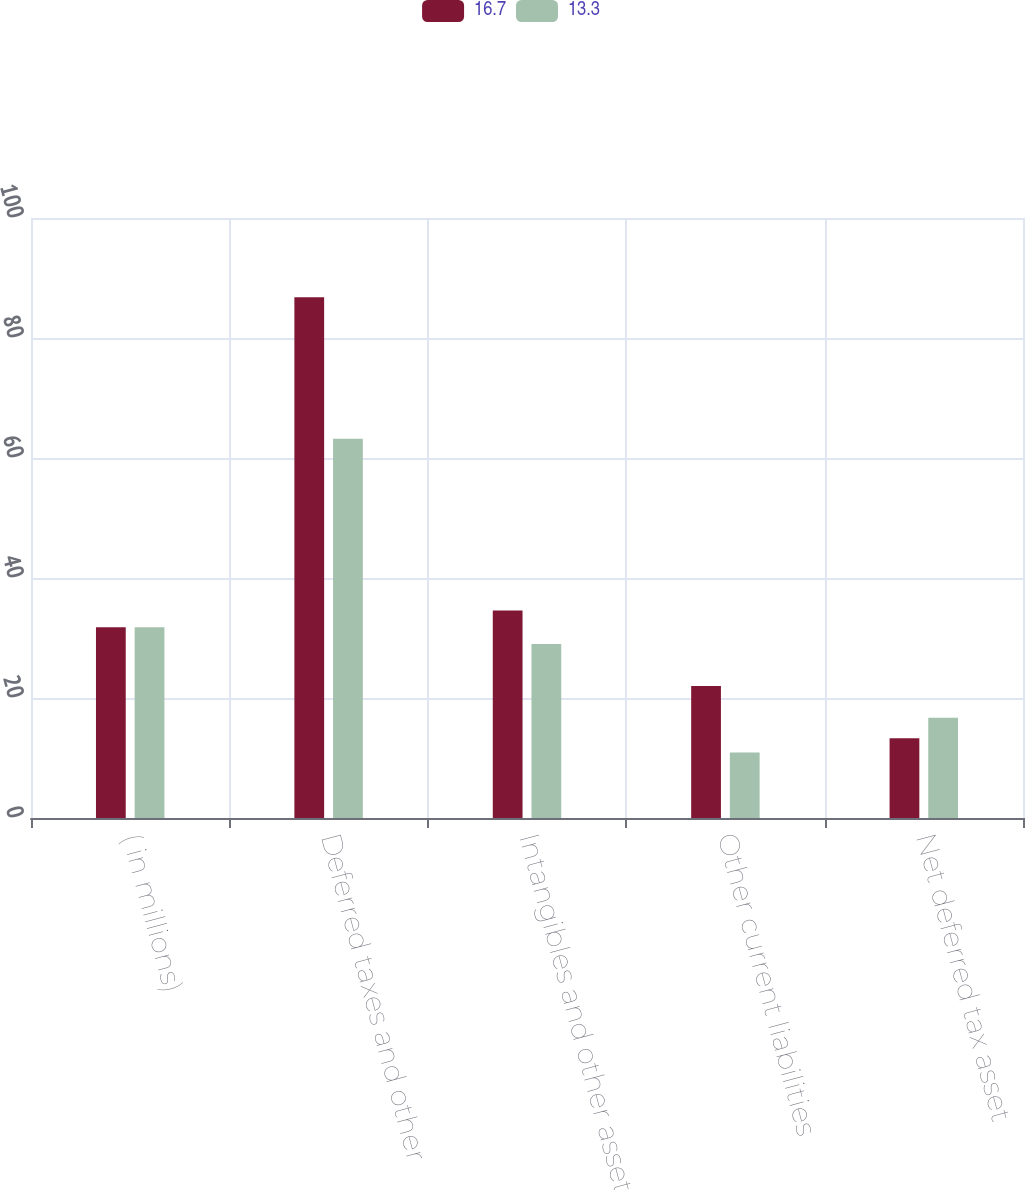<chart> <loc_0><loc_0><loc_500><loc_500><stacked_bar_chart><ecel><fcel>( in millions)<fcel>Deferred taxes and other<fcel>Intangibles and other assets<fcel>Other current liabilities<fcel>Net deferred tax asset<nl><fcel>16.7<fcel>31.8<fcel>86.8<fcel>34.6<fcel>22<fcel>13.3<nl><fcel>13.3<fcel>31.8<fcel>63.2<fcel>29<fcel>10.9<fcel>16.7<nl></chart> 